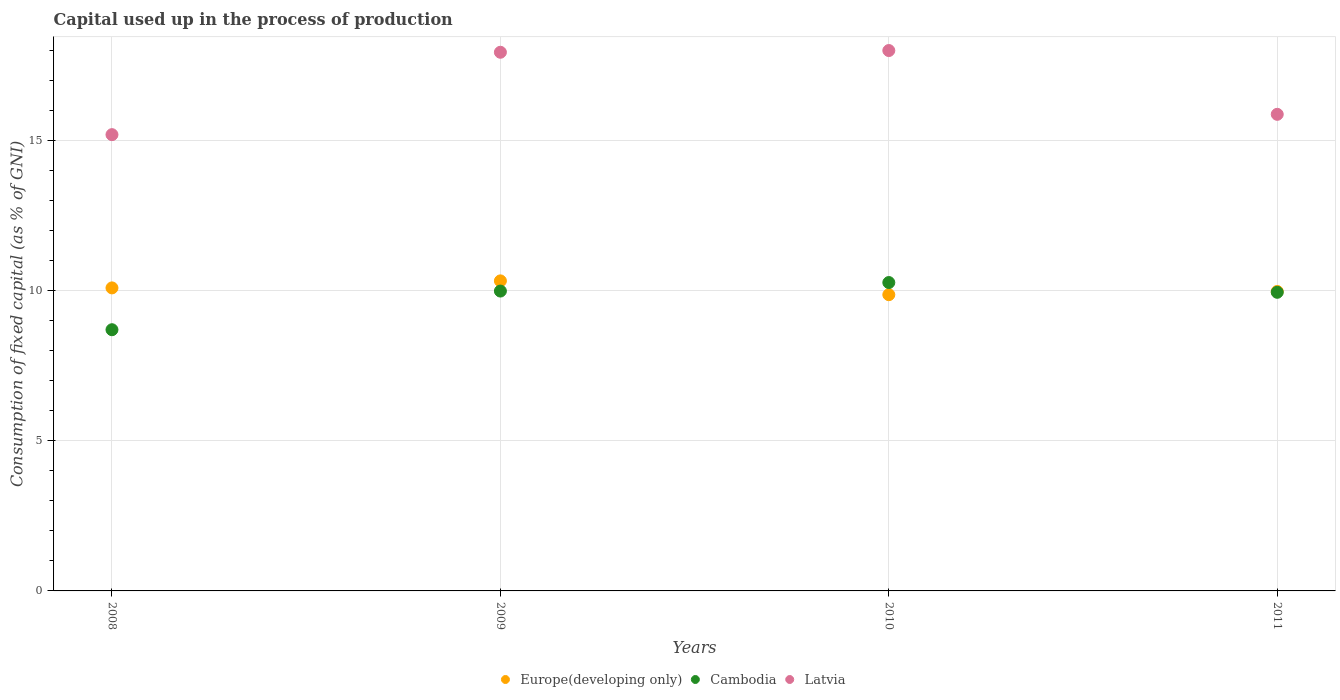Is the number of dotlines equal to the number of legend labels?
Keep it short and to the point. Yes. What is the capital used up in the process of production in Latvia in 2011?
Make the answer very short. 15.87. Across all years, what is the maximum capital used up in the process of production in Europe(developing only)?
Offer a very short reply. 10.32. Across all years, what is the minimum capital used up in the process of production in Latvia?
Provide a short and direct response. 15.19. In which year was the capital used up in the process of production in Cambodia maximum?
Keep it short and to the point. 2010. What is the total capital used up in the process of production in Cambodia in the graph?
Offer a terse response. 38.88. What is the difference between the capital used up in the process of production in Cambodia in 2008 and that in 2009?
Provide a succinct answer. -1.29. What is the difference between the capital used up in the process of production in Cambodia in 2011 and the capital used up in the process of production in Latvia in 2010?
Ensure brevity in your answer.  -8.05. What is the average capital used up in the process of production in Europe(developing only) per year?
Provide a short and direct response. 10.06. In the year 2008, what is the difference between the capital used up in the process of production in Latvia and capital used up in the process of production in Europe(developing only)?
Give a very brief answer. 5.1. In how many years, is the capital used up in the process of production in Latvia greater than 2 %?
Your answer should be very brief. 4. What is the ratio of the capital used up in the process of production in Latvia in 2008 to that in 2011?
Ensure brevity in your answer.  0.96. Is the difference between the capital used up in the process of production in Latvia in 2008 and 2009 greater than the difference between the capital used up in the process of production in Europe(developing only) in 2008 and 2009?
Offer a very short reply. No. What is the difference between the highest and the second highest capital used up in the process of production in Latvia?
Provide a succinct answer. 0.06. What is the difference between the highest and the lowest capital used up in the process of production in Cambodia?
Offer a very short reply. 1.57. In how many years, is the capital used up in the process of production in Latvia greater than the average capital used up in the process of production in Latvia taken over all years?
Keep it short and to the point. 2. Is the sum of the capital used up in the process of production in Cambodia in 2008 and 2009 greater than the maximum capital used up in the process of production in Latvia across all years?
Offer a very short reply. Yes. Is it the case that in every year, the sum of the capital used up in the process of production in Latvia and capital used up in the process of production in Cambodia  is greater than the capital used up in the process of production in Europe(developing only)?
Make the answer very short. Yes. Does the capital used up in the process of production in Cambodia monotonically increase over the years?
Keep it short and to the point. No. Are the values on the major ticks of Y-axis written in scientific E-notation?
Your answer should be very brief. No. Does the graph contain any zero values?
Offer a very short reply. No. How many legend labels are there?
Offer a terse response. 3. How are the legend labels stacked?
Your response must be concise. Horizontal. What is the title of the graph?
Make the answer very short. Capital used up in the process of production. Does "Bangladesh" appear as one of the legend labels in the graph?
Make the answer very short. No. What is the label or title of the Y-axis?
Provide a short and direct response. Consumption of fixed capital (as % of GNI). What is the Consumption of fixed capital (as % of GNI) in Europe(developing only) in 2008?
Provide a succinct answer. 10.09. What is the Consumption of fixed capital (as % of GNI) in Cambodia in 2008?
Your answer should be compact. 8.7. What is the Consumption of fixed capital (as % of GNI) in Latvia in 2008?
Make the answer very short. 15.19. What is the Consumption of fixed capital (as % of GNI) of Europe(developing only) in 2009?
Give a very brief answer. 10.32. What is the Consumption of fixed capital (as % of GNI) in Cambodia in 2009?
Offer a very short reply. 9.98. What is the Consumption of fixed capital (as % of GNI) in Latvia in 2009?
Your response must be concise. 17.93. What is the Consumption of fixed capital (as % of GNI) of Europe(developing only) in 2010?
Offer a terse response. 9.86. What is the Consumption of fixed capital (as % of GNI) in Cambodia in 2010?
Provide a succinct answer. 10.27. What is the Consumption of fixed capital (as % of GNI) of Latvia in 2010?
Provide a short and direct response. 17.99. What is the Consumption of fixed capital (as % of GNI) in Europe(developing only) in 2011?
Your answer should be very brief. 9.97. What is the Consumption of fixed capital (as % of GNI) in Cambodia in 2011?
Provide a succinct answer. 9.94. What is the Consumption of fixed capital (as % of GNI) of Latvia in 2011?
Make the answer very short. 15.87. Across all years, what is the maximum Consumption of fixed capital (as % of GNI) in Europe(developing only)?
Ensure brevity in your answer.  10.32. Across all years, what is the maximum Consumption of fixed capital (as % of GNI) of Cambodia?
Offer a very short reply. 10.27. Across all years, what is the maximum Consumption of fixed capital (as % of GNI) in Latvia?
Your answer should be compact. 17.99. Across all years, what is the minimum Consumption of fixed capital (as % of GNI) of Europe(developing only)?
Your answer should be very brief. 9.86. Across all years, what is the minimum Consumption of fixed capital (as % of GNI) of Cambodia?
Keep it short and to the point. 8.7. Across all years, what is the minimum Consumption of fixed capital (as % of GNI) in Latvia?
Provide a succinct answer. 15.19. What is the total Consumption of fixed capital (as % of GNI) of Europe(developing only) in the graph?
Keep it short and to the point. 40.24. What is the total Consumption of fixed capital (as % of GNI) in Cambodia in the graph?
Your answer should be very brief. 38.88. What is the total Consumption of fixed capital (as % of GNI) of Latvia in the graph?
Ensure brevity in your answer.  66.98. What is the difference between the Consumption of fixed capital (as % of GNI) of Europe(developing only) in 2008 and that in 2009?
Your response must be concise. -0.23. What is the difference between the Consumption of fixed capital (as % of GNI) of Cambodia in 2008 and that in 2009?
Give a very brief answer. -1.29. What is the difference between the Consumption of fixed capital (as % of GNI) of Latvia in 2008 and that in 2009?
Offer a terse response. -2.74. What is the difference between the Consumption of fixed capital (as % of GNI) in Europe(developing only) in 2008 and that in 2010?
Provide a succinct answer. 0.23. What is the difference between the Consumption of fixed capital (as % of GNI) in Cambodia in 2008 and that in 2010?
Keep it short and to the point. -1.57. What is the difference between the Consumption of fixed capital (as % of GNI) in Latvia in 2008 and that in 2010?
Provide a succinct answer. -2.8. What is the difference between the Consumption of fixed capital (as % of GNI) of Europe(developing only) in 2008 and that in 2011?
Your answer should be compact. 0.12. What is the difference between the Consumption of fixed capital (as % of GNI) in Cambodia in 2008 and that in 2011?
Ensure brevity in your answer.  -1.25. What is the difference between the Consumption of fixed capital (as % of GNI) of Latvia in 2008 and that in 2011?
Provide a succinct answer. -0.68. What is the difference between the Consumption of fixed capital (as % of GNI) in Europe(developing only) in 2009 and that in 2010?
Provide a short and direct response. 0.46. What is the difference between the Consumption of fixed capital (as % of GNI) of Cambodia in 2009 and that in 2010?
Offer a very short reply. -0.28. What is the difference between the Consumption of fixed capital (as % of GNI) in Latvia in 2009 and that in 2010?
Give a very brief answer. -0.06. What is the difference between the Consumption of fixed capital (as % of GNI) in Europe(developing only) in 2009 and that in 2011?
Keep it short and to the point. 0.35. What is the difference between the Consumption of fixed capital (as % of GNI) of Cambodia in 2009 and that in 2011?
Your answer should be compact. 0.04. What is the difference between the Consumption of fixed capital (as % of GNI) of Latvia in 2009 and that in 2011?
Provide a short and direct response. 2.07. What is the difference between the Consumption of fixed capital (as % of GNI) in Europe(developing only) in 2010 and that in 2011?
Offer a very short reply. -0.11. What is the difference between the Consumption of fixed capital (as % of GNI) in Cambodia in 2010 and that in 2011?
Your answer should be compact. 0.32. What is the difference between the Consumption of fixed capital (as % of GNI) in Latvia in 2010 and that in 2011?
Your answer should be very brief. 2.12. What is the difference between the Consumption of fixed capital (as % of GNI) of Europe(developing only) in 2008 and the Consumption of fixed capital (as % of GNI) of Cambodia in 2009?
Provide a short and direct response. 0.11. What is the difference between the Consumption of fixed capital (as % of GNI) of Europe(developing only) in 2008 and the Consumption of fixed capital (as % of GNI) of Latvia in 2009?
Give a very brief answer. -7.84. What is the difference between the Consumption of fixed capital (as % of GNI) of Cambodia in 2008 and the Consumption of fixed capital (as % of GNI) of Latvia in 2009?
Give a very brief answer. -9.24. What is the difference between the Consumption of fixed capital (as % of GNI) in Europe(developing only) in 2008 and the Consumption of fixed capital (as % of GNI) in Cambodia in 2010?
Your response must be concise. -0.18. What is the difference between the Consumption of fixed capital (as % of GNI) in Europe(developing only) in 2008 and the Consumption of fixed capital (as % of GNI) in Latvia in 2010?
Your answer should be very brief. -7.9. What is the difference between the Consumption of fixed capital (as % of GNI) of Cambodia in 2008 and the Consumption of fixed capital (as % of GNI) of Latvia in 2010?
Keep it short and to the point. -9.29. What is the difference between the Consumption of fixed capital (as % of GNI) of Europe(developing only) in 2008 and the Consumption of fixed capital (as % of GNI) of Cambodia in 2011?
Offer a terse response. 0.15. What is the difference between the Consumption of fixed capital (as % of GNI) of Europe(developing only) in 2008 and the Consumption of fixed capital (as % of GNI) of Latvia in 2011?
Provide a succinct answer. -5.78. What is the difference between the Consumption of fixed capital (as % of GNI) in Cambodia in 2008 and the Consumption of fixed capital (as % of GNI) in Latvia in 2011?
Give a very brief answer. -7.17. What is the difference between the Consumption of fixed capital (as % of GNI) of Europe(developing only) in 2009 and the Consumption of fixed capital (as % of GNI) of Cambodia in 2010?
Make the answer very short. 0.06. What is the difference between the Consumption of fixed capital (as % of GNI) of Europe(developing only) in 2009 and the Consumption of fixed capital (as % of GNI) of Latvia in 2010?
Your response must be concise. -7.67. What is the difference between the Consumption of fixed capital (as % of GNI) in Cambodia in 2009 and the Consumption of fixed capital (as % of GNI) in Latvia in 2010?
Make the answer very short. -8.01. What is the difference between the Consumption of fixed capital (as % of GNI) of Europe(developing only) in 2009 and the Consumption of fixed capital (as % of GNI) of Cambodia in 2011?
Provide a succinct answer. 0.38. What is the difference between the Consumption of fixed capital (as % of GNI) in Europe(developing only) in 2009 and the Consumption of fixed capital (as % of GNI) in Latvia in 2011?
Give a very brief answer. -5.54. What is the difference between the Consumption of fixed capital (as % of GNI) in Cambodia in 2009 and the Consumption of fixed capital (as % of GNI) in Latvia in 2011?
Offer a very short reply. -5.88. What is the difference between the Consumption of fixed capital (as % of GNI) of Europe(developing only) in 2010 and the Consumption of fixed capital (as % of GNI) of Cambodia in 2011?
Your answer should be very brief. -0.08. What is the difference between the Consumption of fixed capital (as % of GNI) of Europe(developing only) in 2010 and the Consumption of fixed capital (as % of GNI) of Latvia in 2011?
Provide a succinct answer. -6. What is the difference between the Consumption of fixed capital (as % of GNI) of Cambodia in 2010 and the Consumption of fixed capital (as % of GNI) of Latvia in 2011?
Give a very brief answer. -5.6. What is the average Consumption of fixed capital (as % of GNI) in Europe(developing only) per year?
Provide a short and direct response. 10.06. What is the average Consumption of fixed capital (as % of GNI) in Cambodia per year?
Offer a terse response. 9.72. What is the average Consumption of fixed capital (as % of GNI) of Latvia per year?
Make the answer very short. 16.74. In the year 2008, what is the difference between the Consumption of fixed capital (as % of GNI) in Europe(developing only) and Consumption of fixed capital (as % of GNI) in Cambodia?
Give a very brief answer. 1.39. In the year 2008, what is the difference between the Consumption of fixed capital (as % of GNI) in Europe(developing only) and Consumption of fixed capital (as % of GNI) in Latvia?
Provide a short and direct response. -5.1. In the year 2008, what is the difference between the Consumption of fixed capital (as % of GNI) in Cambodia and Consumption of fixed capital (as % of GNI) in Latvia?
Your answer should be very brief. -6.49. In the year 2009, what is the difference between the Consumption of fixed capital (as % of GNI) in Europe(developing only) and Consumption of fixed capital (as % of GNI) in Cambodia?
Make the answer very short. 0.34. In the year 2009, what is the difference between the Consumption of fixed capital (as % of GNI) in Europe(developing only) and Consumption of fixed capital (as % of GNI) in Latvia?
Offer a very short reply. -7.61. In the year 2009, what is the difference between the Consumption of fixed capital (as % of GNI) in Cambodia and Consumption of fixed capital (as % of GNI) in Latvia?
Provide a succinct answer. -7.95. In the year 2010, what is the difference between the Consumption of fixed capital (as % of GNI) in Europe(developing only) and Consumption of fixed capital (as % of GNI) in Cambodia?
Ensure brevity in your answer.  -0.4. In the year 2010, what is the difference between the Consumption of fixed capital (as % of GNI) of Europe(developing only) and Consumption of fixed capital (as % of GNI) of Latvia?
Your answer should be compact. -8.13. In the year 2010, what is the difference between the Consumption of fixed capital (as % of GNI) of Cambodia and Consumption of fixed capital (as % of GNI) of Latvia?
Keep it short and to the point. -7.72. In the year 2011, what is the difference between the Consumption of fixed capital (as % of GNI) in Europe(developing only) and Consumption of fixed capital (as % of GNI) in Cambodia?
Keep it short and to the point. 0.03. In the year 2011, what is the difference between the Consumption of fixed capital (as % of GNI) in Europe(developing only) and Consumption of fixed capital (as % of GNI) in Latvia?
Provide a short and direct response. -5.9. In the year 2011, what is the difference between the Consumption of fixed capital (as % of GNI) in Cambodia and Consumption of fixed capital (as % of GNI) in Latvia?
Ensure brevity in your answer.  -5.92. What is the ratio of the Consumption of fixed capital (as % of GNI) of Europe(developing only) in 2008 to that in 2009?
Ensure brevity in your answer.  0.98. What is the ratio of the Consumption of fixed capital (as % of GNI) in Cambodia in 2008 to that in 2009?
Provide a succinct answer. 0.87. What is the ratio of the Consumption of fixed capital (as % of GNI) of Latvia in 2008 to that in 2009?
Your answer should be compact. 0.85. What is the ratio of the Consumption of fixed capital (as % of GNI) in Europe(developing only) in 2008 to that in 2010?
Offer a terse response. 1.02. What is the ratio of the Consumption of fixed capital (as % of GNI) in Cambodia in 2008 to that in 2010?
Offer a terse response. 0.85. What is the ratio of the Consumption of fixed capital (as % of GNI) in Latvia in 2008 to that in 2010?
Your answer should be very brief. 0.84. What is the ratio of the Consumption of fixed capital (as % of GNI) of Europe(developing only) in 2008 to that in 2011?
Offer a very short reply. 1.01. What is the ratio of the Consumption of fixed capital (as % of GNI) in Cambodia in 2008 to that in 2011?
Keep it short and to the point. 0.87. What is the ratio of the Consumption of fixed capital (as % of GNI) in Latvia in 2008 to that in 2011?
Provide a succinct answer. 0.96. What is the ratio of the Consumption of fixed capital (as % of GNI) in Europe(developing only) in 2009 to that in 2010?
Provide a short and direct response. 1.05. What is the ratio of the Consumption of fixed capital (as % of GNI) of Cambodia in 2009 to that in 2010?
Your answer should be compact. 0.97. What is the ratio of the Consumption of fixed capital (as % of GNI) of Europe(developing only) in 2009 to that in 2011?
Your answer should be very brief. 1.04. What is the ratio of the Consumption of fixed capital (as % of GNI) of Cambodia in 2009 to that in 2011?
Provide a succinct answer. 1. What is the ratio of the Consumption of fixed capital (as % of GNI) of Latvia in 2009 to that in 2011?
Give a very brief answer. 1.13. What is the ratio of the Consumption of fixed capital (as % of GNI) in Cambodia in 2010 to that in 2011?
Your answer should be compact. 1.03. What is the ratio of the Consumption of fixed capital (as % of GNI) in Latvia in 2010 to that in 2011?
Give a very brief answer. 1.13. What is the difference between the highest and the second highest Consumption of fixed capital (as % of GNI) of Europe(developing only)?
Keep it short and to the point. 0.23. What is the difference between the highest and the second highest Consumption of fixed capital (as % of GNI) in Cambodia?
Give a very brief answer. 0.28. What is the difference between the highest and the second highest Consumption of fixed capital (as % of GNI) of Latvia?
Ensure brevity in your answer.  0.06. What is the difference between the highest and the lowest Consumption of fixed capital (as % of GNI) in Europe(developing only)?
Offer a terse response. 0.46. What is the difference between the highest and the lowest Consumption of fixed capital (as % of GNI) in Cambodia?
Offer a very short reply. 1.57. What is the difference between the highest and the lowest Consumption of fixed capital (as % of GNI) in Latvia?
Keep it short and to the point. 2.8. 